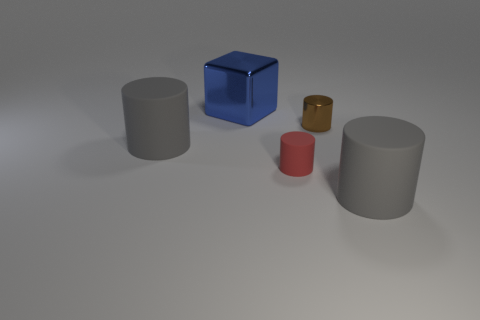Are any tiny blue rubber balls visible?
Your response must be concise. No. How many big matte things are the same color as the small matte thing?
Your answer should be very brief. 0. How big is the gray rubber thing that is behind the big matte cylinder right of the large blue shiny cube?
Your answer should be very brief. Large. Is there a tiny red cylinder made of the same material as the small red thing?
Provide a short and direct response. No. What material is the red cylinder that is the same size as the brown metallic object?
Offer a terse response. Rubber. Do the big matte thing that is behind the red matte thing and the thing behind the small brown shiny object have the same color?
Offer a very short reply. No. There is a matte object behind the red matte cylinder; is there a red thing that is left of it?
Provide a succinct answer. No. There is a large matte thing that is behind the tiny matte cylinder; is it the same shape as the metallic object that is right of the red matte cylinder?
Your answer should be compact. Yes. Is the material of the object left of the big block the same as the large object that is on the right side of the small metal object?
Ensure brevity in your answer.  Yes. There is a gray thing to the right of the small thing in front of the small brown metallic thing; what is its material?
Make the answer very short. Rubber. 